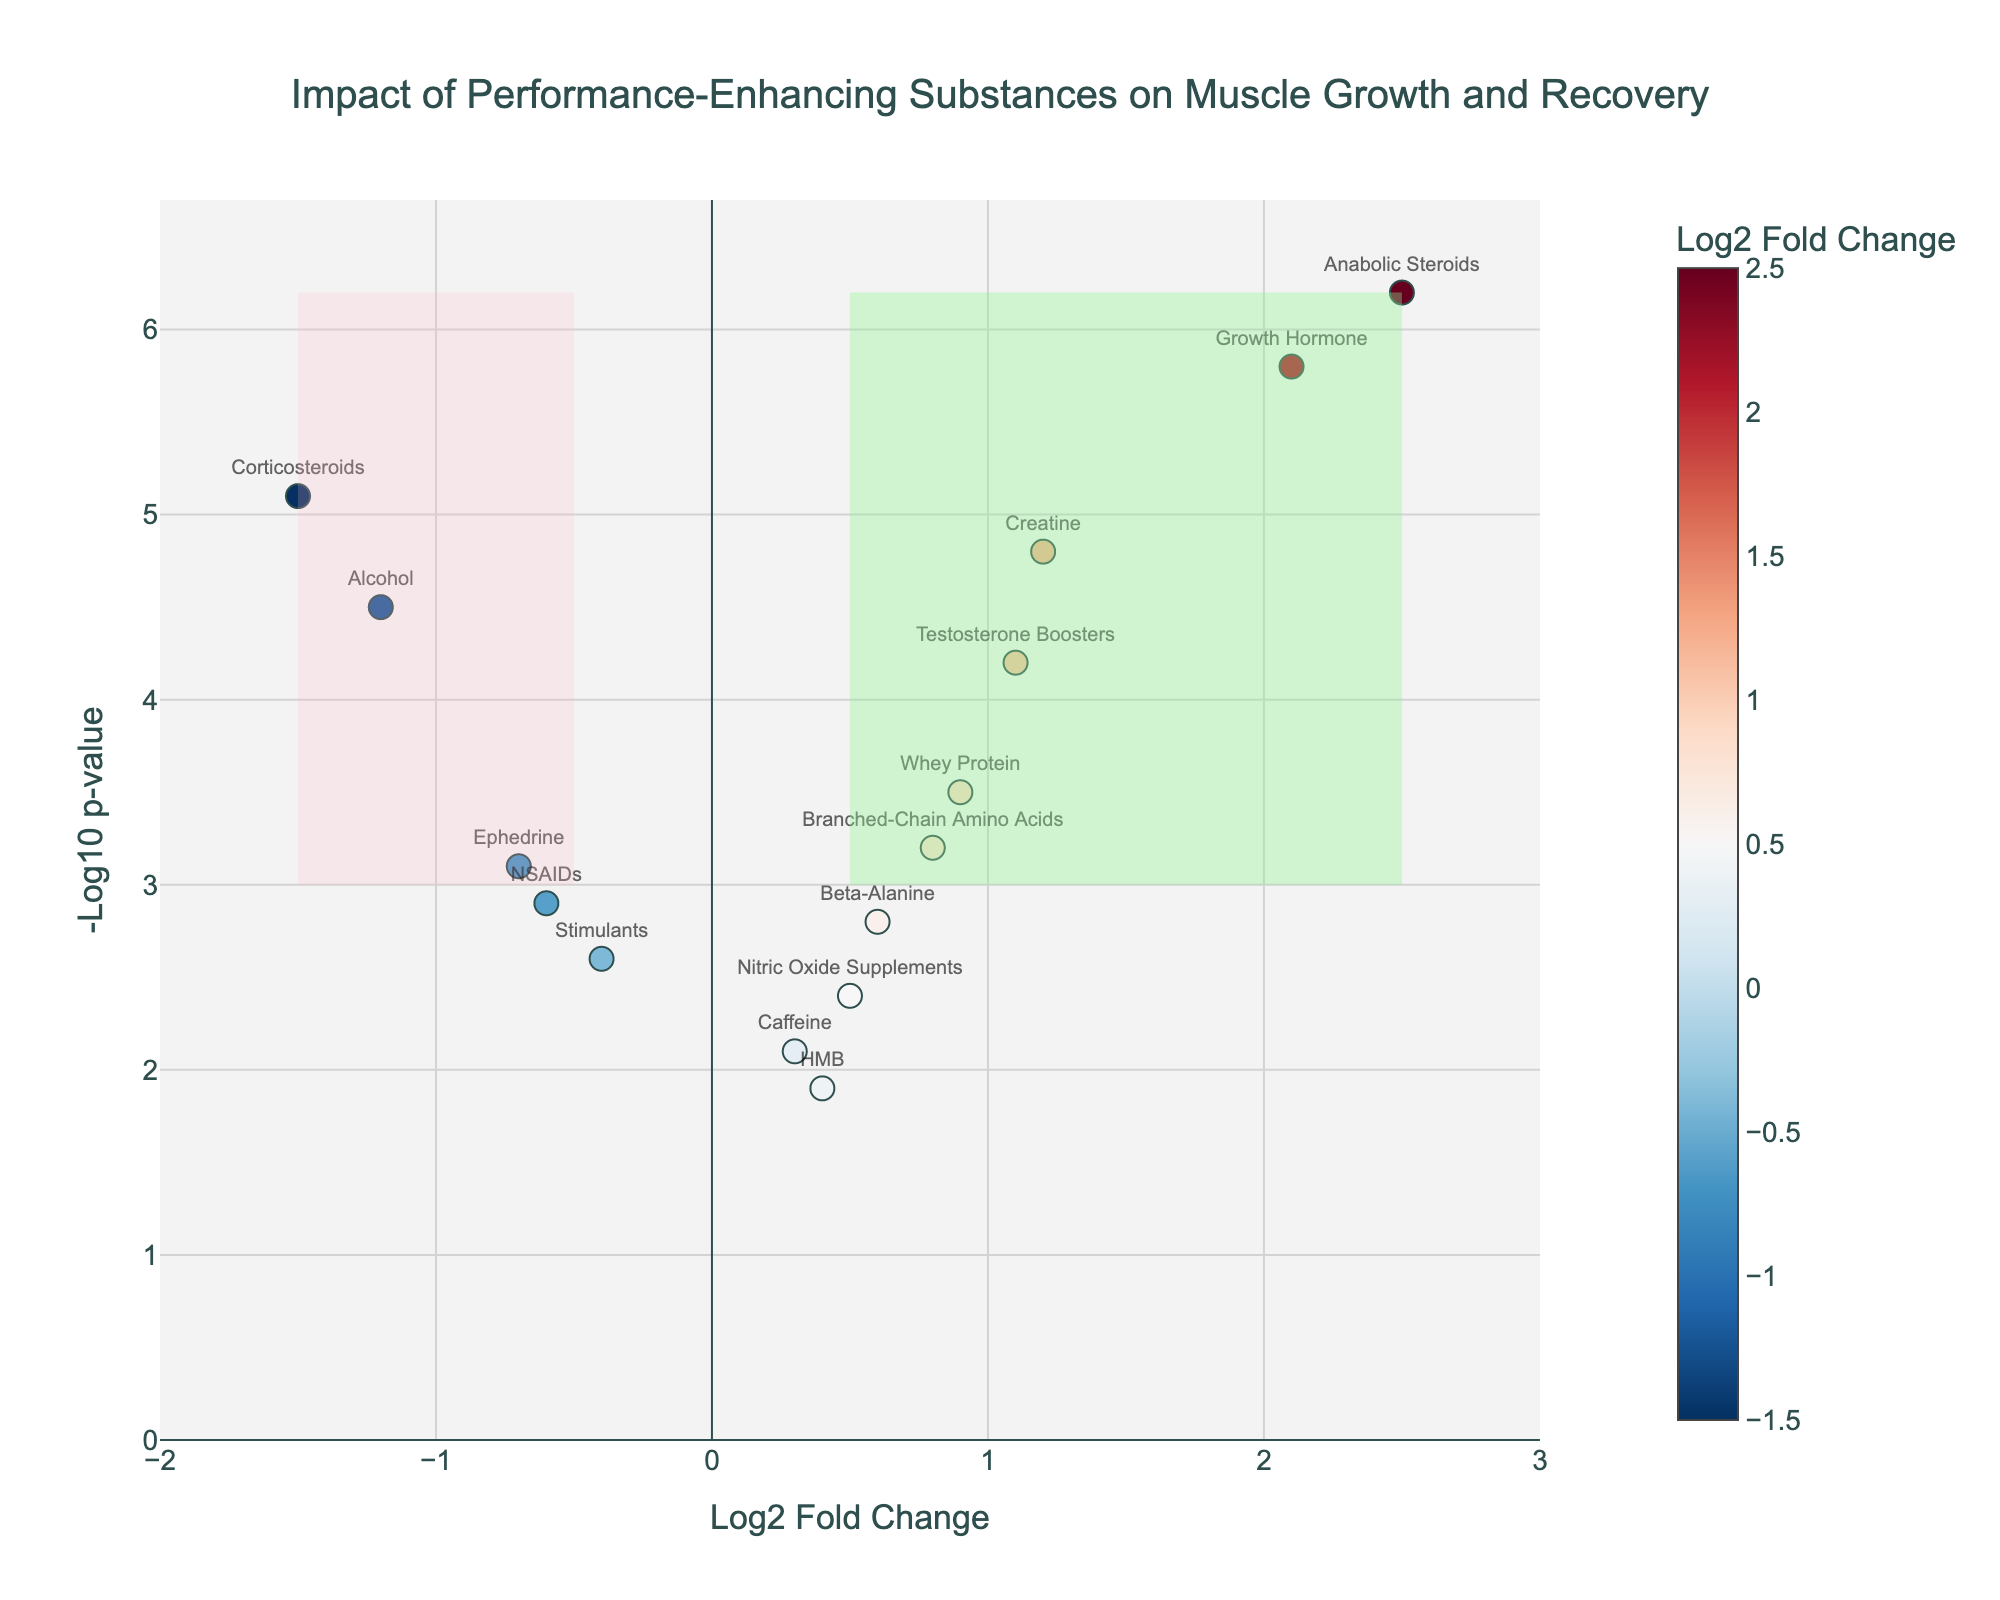What is the title of the plot? The title of the plot can be found at the top center and gives an overall idea of what the data represents.
Answer: Impact of Performance-Enhancing Substances on Muscle Growth and Recovery What are the axes titles of the plot? The x-axis and y-axis titles provide information about the variables being plotted. The x-axis is labeled "Log2 Fold Change" and the y-axis is labeled "-Log10 p-value".
Answer: Log2 Fold Change and -Log10 p-value How many substances have a positive Log2 Fold Change value greater than 1.0? To determine the number of substances with a Log2 Fold Change greater than 1.0, look at how many points are to the right of the 1.0 mark on the x-axis. These substances would have positive Log2 Fold Change values.
Answer: 3 Which substances are in the detrimental effect area of the plot? The detrimental effect area is shaded with LightPink color and is on the left side of the vertical threshold line at -0.5 Log2 Fold Change. Look at which substances fall into this area.
Answer: Ephedrine, Alcohol, and Corticosteroids Which substance has the highest -Log10 p-value? Identify the point that lies highest along the y-axis. This will have the highest -Log10 p-value, which reflects the most statistically significant result.
Answer: Anabolic Steroids Compare the Log2 Fold Changes of Whey Protein and Beta-Alanine. Which one is higher? Locate the points representing Whey Protein and Beta-Alanine on the x-axis and compare their positions. The point further to the right has a higher Log2 Fold Change.
Answer: Whey Protein What is the only substance with a negative Log2 Fold Change and -Log10 p-value greater than 4? Look for the substances on the left side (negative Log2 Fold Change) and above the horizontal line at -Log10 p-value of 4.
Answer: Alcohol Which quadrant represents the beneficial effects with statistical significance? The quadrant representing beneficial effects with statistical significance is on the right of the vertical line at Log2 Fold Change of 0.5 and above the horizontal line at -Log10 p-value of 3. This area is shaded LightGreen.
Answer: Top right How many substances have a -Log10 p-value greater than 5.0? Count the number of substances that lie above the 5.0 mark on the y-axis. This gives the number of substances with high statistical significance.
Answer: 2 What substance lies just below the -Log10 p-value threshold of 3 but has a positive Log2 Fold Change? Identify the substance that is slightly below the horizontal threshold line at -Log10 p-value of 3 and to the right of the vertical line at 0 on the x-axis.
Answer: Caffeine 